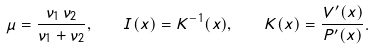Convert formula to latex. <formula><loc_0><loc_0><loc_500><loc_500>\mu = \frac { \nu _ { 1 } \, \nu _ { 2 } } { \nu _ { 1 } + \nu _ { 2 } } , \quad I ( x ) = K ^ { - 1 } ( x ) , \quad K ( x ) = \frac { V ^ { \prime } ( x ) } { P ^ { \prime } ( x ) } .</formula> 